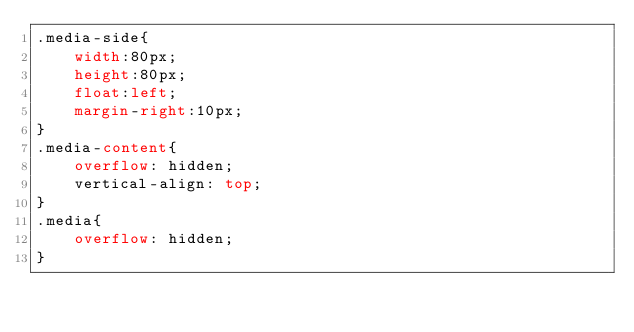<code> <loc_0><loc_0><loc_500><loc_500><_CSS_>.media-side{
    width:80px;
    height:80px;
    float:left;
    margin-right:10px;
}
.media-content{
    overflow: hidden;
    vertical-align: top;
}
.media{
    overflow: hidden;
}
</code> 